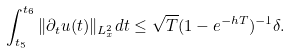Convert formula to latex. <formula><loc_0><loc_0><loc_500><loc_500>\int _ { t _ { 5 } } ^ { t _ { 6 } } \| \partial _ { t } u ( t ) \| _ { L ^ { 2 } _ { x } } d t \leq \sqrt { T } ( 1 - e ^ { - h T } ) ^ { - 1 } \delta .</formula> 